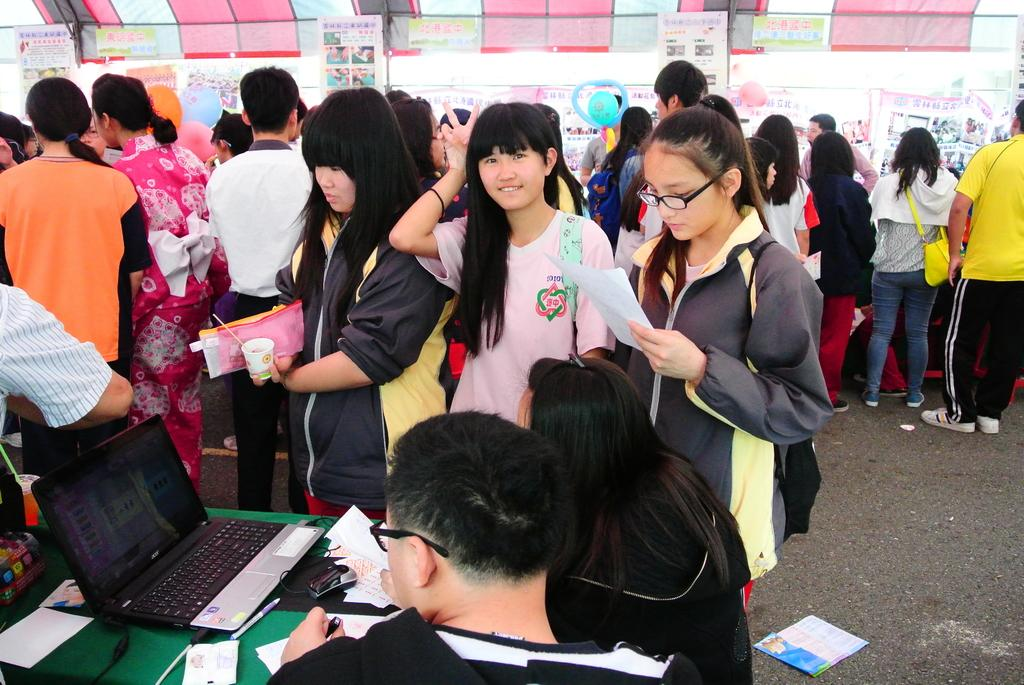How many people are in the image? There is a group of people in the image. What is present on the table in the image? There is a laptop, pens, papers, and other objects on the table. What device can be seen on the table in the image? There is a laptop on the table. What might be used for writing in the image? Pens are present on the table for writing. What type of balls are being used for the meeting in the image? There is no meeting or balls present in the image. Can you describe the toes of the people in the image? There is no reference to toes in the image, as it focuses on a group of people, a table, and various objects on the table. 